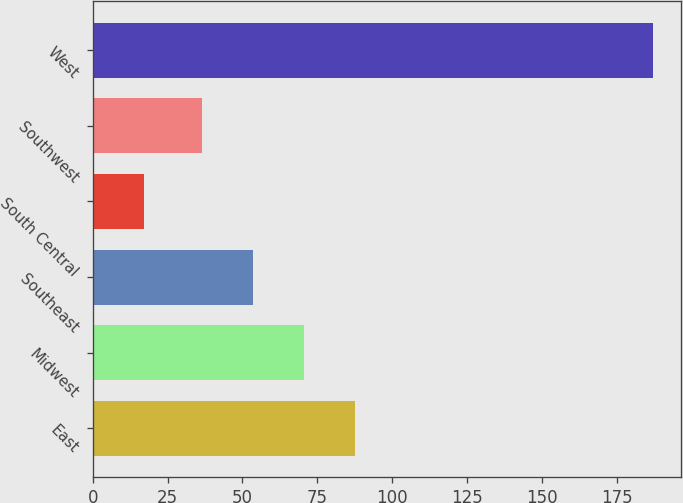<chart> <loc_0><loc_0><loc_500><loc_500><bar_chart><fcel>East<fcel>Midwest<fcel>Southeast<fcel>South Central<fcel>Southwest<fcel>West<nl><fcel>87.5<fcel>70.5<fcel>53.5<fcel>17<fcel>36.5<fcel>187<nl></chart> 